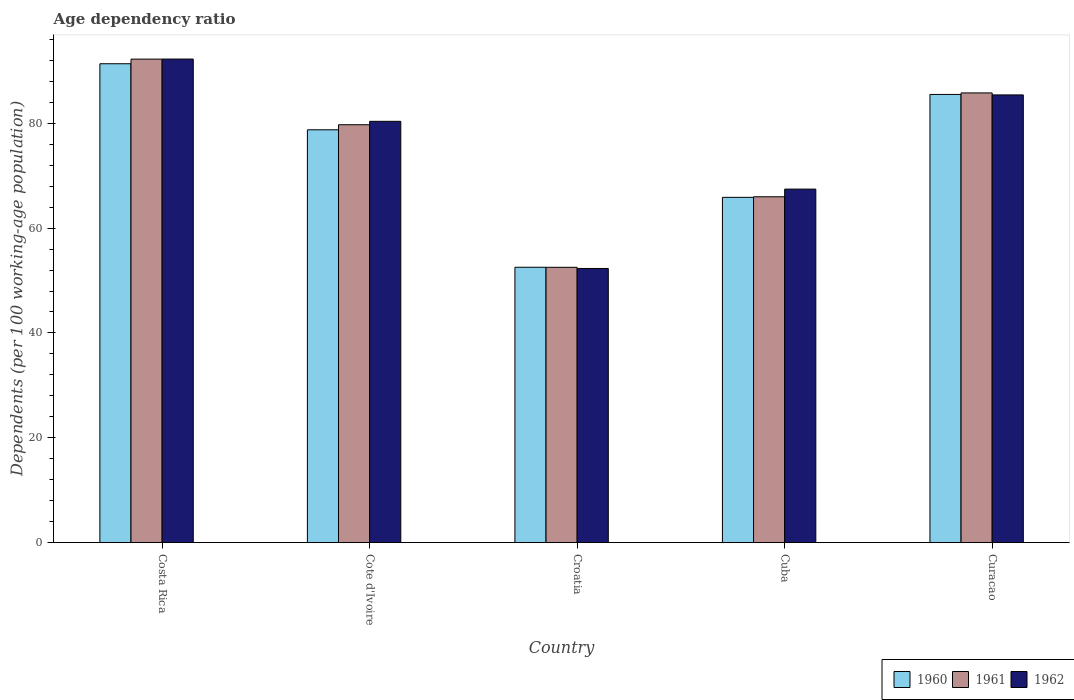How many different coloured bars are there?
Provide a succinct answer. 3. How many groups of bars are there?
Provide a short and direct response. 5. Are the number of bars per tick equal to the number of legend labels?
Your response must be concise. Yes. What is the label of the 3rd group of bars from the left?
Offer a terse response. Croatia. What is the age dependency ratio in in 1960 in Cuba?
Offer a terse response. 65.87. Across all countries, what is the maximum age dependency ratio in in 1962?
Provide a short and direct response. 92.26. Across all countries, what is the minimum age dependency ratio in in 1961?
Your response must be concise. 52.52. In which country was the age dependency ratio in in 1961 maximum?
Your response must be concise. Costa Rica. In which country was the age dependency ratio in in 1962 minimum?
Make the answer very short. Croatia. What is the total age dependency ratio in in 1962 in the graph?
Provide a succinct answer. 377.8. What is the difference between the age dependency ratio in in 1962 in Cote d'Ivoire and that in Curacao?
Provide a succinct answer. -5.04. What is the difference between the age dependency ratio in in 1960 in Curacao and the age dependency ratio in in 1961 in Croatia?
Provide a succinct answer. 32.98. What is the average age dependency ratio in in 1960 per country?
Your answer should be very brief. 74.81. What is the difference between the age dependency ratio in of/in 1960 and age dependency ratio in of/in 1961 in Cote d'Ivoire?
Offer a terse response. -0.97. What is the ratio of the age dependency ratio in in 1962 in Costa Rica to that in Curacao?
Ensure brevity in your answer.  1.08. Is the age dependency ratio in in 1961 in Croatia less than that in Curacao?
Keep it short and to the point. Yes. What is the difference between the highest and the second highest age dependency ratio in in 1961?
Keep it short and to the point. 6.45. What is the difference between the highest and the lowest age dependency ratio in in 1962?
Your response must be concise. 39.96. In how many countries, is the age dependency ratio in in 1962 greater than the average age dependency ratio in in 1962 taken over all countries?
Keep it short and to the point. 3. What does the 1st bar from the left in Costa Rica represents?
Your answer should be compact. 1960. What does the 1st bar from the right in Costa Rica represents?
Provide a short and direct response. 1962. Is it the case that in every country, the sum of the age dependency ratio in in 1960 and age dependency ratio in in 1962 is greater than the age dependency ratio in in 1961?
Provide a succinct answer. Yes. Are the values on the major ticks of Y-axis written in scientific E-notation?
Your answer should be compact. No. Does the graph contain grids?
Offer a very short reply. No. How many legend labels are there?
Your response must be concise. 3. What is the title of the graph?
Provide a short and direct response. Age dependency ratio. What is the label or title of the X-axis?
Give a very brief answer. Country. What is the label or title of the Y-axis?
Keep it short and to the point. Dependents (per 100 working-age population). What is the Dependents (per 100 working-age population) in 1960 in Costa Rica?
Your answer should be compact. 91.36. What is the Dependents (per 100 working-age population) of 1961 in Costa Rica?
Ensure brevity in your answer.  92.25. What is the Dependents (per 100 working-age population) in 1962 in Costa Rica?
Ensure brevity in your answer.  92.26. What is the Dependents (per 100 working-age population) of 1960 in Cote d'Ivoire?
Your response must be concise. 78.76. What is the Dependents (per 100 working-age population) in 1961 in Cote d'Ivoire?
Your answer should be compact. 79.73. What is the Dependents (per 100 working-age population) in 1962 in Cote d'Ivoire?
Provide a succinct answer. 80.38. What is the Dependents (per 100 working-age population) in 1960 in Croatia?
Keep it short and to the point. 52.53. What is the Dependents (per 100 working-age population) in 1961 in Croatia?
Your answer should be compact. 52.52. What is the Dependents (per 100 working-age population) of 1962 in Croatia?
Make the answer very short. 52.3. What is the Dependents (per 100 working-age population) in 1960 in Cuba?
Provide a succinct answer. 65.87. What is the Dependents (per 100 working-age population) in 1961 in Cuba?
Provide a succinct answer. 65.98. What is the Dependents (per 100 working-age population) of 1962 in Cuba?
Your response must be concise. 67.44. What is the Dependents (per 100 working-age population) of 1960 in Curacao?
Offer a very short reply. 85.5. What is the Dependents (per 100 working-age population) in 1961 in Curacao?
Your answer should be very brief. 85.8. What is the Dependents (per 100 working-age population) in 1962 in Curacao?
Offer a terse response. 85.42. Across all countries, what is the maximum Dependents (per 100 working-age population) in 1960?
Make the answer very short. 91.36. Across all countries, what is the maximum Dependents (per 100 working-age population) of 1961?
Give a very brief answer. 92.25. Across all countries, what is the maximum Dependents (per 100 working-age population) of 1962?
Your answer should be compact. 92.26. Across all countries, what is the minimum Dependents (per 100 working-age population) in 1960?
Provide a short and direct response. 52.53. Across all countries, what is the minimum Dependents (per 100 working-age population) of 1961?
Make the answer very short. 52.52. Across all countries, what is the minimum Dependents (per 100 working-age population) in 1962?
Provide a short and direct response. 52.3. What is the total Dependents (per 100 working-age population) of 1960 in the graph?
Offer a very short reply. 374.03. What is the total Dependents (per 100 working-age population) in 1961 in the graph?
Keep it short and to the point. 376.28. What is the total Dependents (per 100 working-age population) in 1962 in the graph?
Your response must be concise. 377.8. What is the difference between the Dependents (per 100 working-age population) of 1960 in Costa Rica and that in Cote d'Ivoire?
Your answer should be compact. 12.6. What is the difference between the Dependents (per 100 working-age population) of 1961 in Costa Rica and that in Cote d'Ivoire?
Offer a terse response. 12.52. What is the difference between the Dependents (per 100 working-age population) in 1962 in Costa Rica and that in Cote d'Ivoire?
Provide a short and direct response. 11.88. What is the difference between the Dependents (per 100 working-age population) in 1960 in Costa Rica and that in Croatia?
Keep it short and to the point. 38.83. What is the difference between the Dependents (per 100 working-age population) in 1961 in Costa Rica and that in Croatia?
Provide a succinct answer. 39.72. What is the difference between the Dependents (per 100 working-age population) of 1962 in Costa Rica and that in Croatia?
Provide a short and direct response. 39.96. What is the difference between the Dependents (per 100 working-age population) in 1960 in Costa Rica and that in Cuba?
Provide a short and direct response. 25.49. What is the difference between the Dependents (per 100 working-age population) in 1961 in Costa Rica and that in Cuba?
Your answer should be very brief. 26.27. What is the difference between the Dependents (per 100 working-age population) in 1962 in Costa Rica and that in Cuba?
Offer a terse response. 24.81. What is the difference between the Dependents (per 100 working-age population) in 1960 in Costa Rica and that in Curacao?
Your answer should be very brief. 5.86. What is the difference between the Dependents (per 100 working-age population) of 1961 in Costa Rica and that in Curacao?
Give a very brief answer. 6.45. What is the difference between the Dependents (per 100 working-age population) of 1962 in Costa Rica and that in Curacao?
Offer a terse response. 6.84. What is the difference between the Dependents (per 100 working-age population) of 1960 in Cote d'Ivoire and that in Croatia?
Offer a terse response. 26.23. What is the difference between the Dependents (per 100 working-age population) in 1961 in Cote d'Ivoire and that in Croatia?
Provide a short and direct response. 27.2. What is the difference between the Dependents (per 100 working-age population) in 1962 in Cote d'Ivoire and that in Croatia?
Ensure brevity in your answer.  28.08. What is the difference between the Dependents (per 100 working-age population) of 1960 in Cote d'Ivoire and that in Cuba?
Offer a terse response. 12.89. What is the difference between the Dependents (per 100 working-age population) of 1961 in Cote d'Ivoire and that in Cuba?
Your response must be concise. 13.75. What is the difference between the Dependents (per 100 working-age population) of 1962 in Cote d'Ivoire and that in Cuba?
Ensure brevity in your answer.  12.93. What is the difference between the Dependents (per 100 working-age population) in 1960 in Cote d'Ivoire and that in Curacao?
Offer a very short reply. -6.75. What is the difference between the Dependents (per 100 working-age population) in 1961 in Cote d'Ivoire and that in Curacao?
Your response must be concise. -6.07. What is the difference between the Dependents (per 100 working-age population) of 1962 in Cote d'Ivoire and that in Curacao?
Provide a succinct answer. -5.04. What is the difference between the Dependents (per 100 working-age population) of 1960 in Croatia and that in Cuba?
Your response must be concise. -13.34. What is the difference between the Dependents (per 100 working-age population) of 1961 in Croatia and that in Cuba?
Offer a very short reply. -13.46. What is the difference between the Dependents (per 100 working-age population) of 1962 in Croatia and that in Cuba?
Offer a very short reply. -15.14. What is the difference between the Dependents (per 100 working-age population) in 1960 in Croatia and that in Curacao?
Keep it short and to the point. -32.97. What is the difference between the Dependents (per 100 working-age population) in 1961 in Croatia and that in Curacao?
Provide a short and direct response. -33.27. What is the difference between the Dependents (per 100 working-age population) in 1962 in Croatia and that in Curacao?
Your answer should be compact. -33.12. What is the difference between the Dependents (per 100 working-age population) of 1960 in Cuba and that in Curacao?
Offer a very short reply. -19.63. What is the difference between the Dependents (per 100 working-age population) of 1961 in Cuba and that in Curacao?
Your answer should be very brief. -19.82. What is the difference between the Dependents (per 100 working-age population) in 1962 in Cuba and that in Curacao?
Give a very brief answer. -17.97. What is the difference between the Dependents (per 100 working-age population) of 1960 in Costa Rica and the Dependents (per 100 working-age population) of 1961 in Cote d'Ivoire?
Offer a very short reply. 11.63. What is the difference between the Dependents (per 100 working-age population) in 1960 in Costa Rica and the Dependents (per 100 working-age population) in 1962 in Cote d'Ivoire?
Offer a terse response. 10.98. What is the difference between the Dependents (per 100 working-age population) of 1961 in Costa Rica and the Dependents (per 100 working-age population) of 1962 in Cote d'Ivoire?
Ensure brevity in your answer.  11.87. What is the difference between the Dependents (per 100 working-age population) of 1960 in Costa Rica and the Dependents (per 100 working-age population) of 1961 in Croatia?
Give a very brief answer. 38.84. What is the difference between the Dependents (per 100 working-age population) in 1960 in Costa Rica and the Dependents (per 100 working-age population) in 1962 in Croatia?
Offer a very short reply. 39.06. What is the difference between the Dependents (per 100 working-age population) in 1961 in Costa Rica and the Dependents (per 100 working-age population) in 1962 in Croatia?
Make the answer very short. 39.95. What is the difference between the Dependents (per 100 working-age population) of 1960 in Costa Rica and the Dependents (per 100 working-age population) of 1961 in Cuba?
Give a very brief answer. 25.38. What is the difference between the Dependents (per 100 working-age population) of 1960 in Costa Rica and the Dependents (per 100 working-age population) of 1962 in Cuba?
Your answer should be compact. 23.92. What is the difference between the Dependents (per 100 working-age population) in 1961 in Costa Rica and the Dependents (per 100 working-age population) in 1962 in Cuba?
Ensure brevity in your answer.  24.8. What is the difference between the Dependents (per 100 working-age population) of 1960 in Costa Rica and the Dependents (per 100 working-age population) of 1961 in Curacao?
Your answer should be compact. 5.57. What is the difference between the Dependents (per 100 working-age population) of 1960 in Costa Rica and the Dependents (per 100 working-age population) of 1962 in Curacao?
Provide a short and direct response. 5.95. What is the difference between the Dependents (per 100 working-age population) in 1961 in Costa Rica and the Dependents (per 100 working-age population) in 1962 in Curacao?
Ensure brevity in your answer.  6.83. What is the difference between the Dependents (per 100 working-age population) of 1960 in Cote d'Ivoire and the Dependents (per 100 working-age population) of 1961 in Croatia?
Ensure brevity in your answer.  26.23. What is the difference between the Dependents (per 100 working-age population) in 1960 in Cote d'Ivoire and the Dependents (per 100 working-age population) in 1962 in Croatia?
Offer a very short reply. 26.46. What is the difference between the Dependents (per 100 working-age population) in 1961 in Cote d'Ivoire and the Dependents (per 100 working-age population) in 1962 in Croatia?
Your answer should be very brief. 27.43. What is the difference between the Dependents (per 100 working-age population) in 1960 in Cote d'Ivoire and the Dependents (per 100 working-age population) in 1961 in Cuba?
Provide a succinct answer. 12.78. What is the difference between the Dependents (per 100 working-age population) in 1960 in Cote d'Ivoire and the Dependents (per 100 working-age population) in 1962 in Cuba?
Keep it short and to the point. 11.31. What is the difference between the Dependents (per 100 working-age population) of 1961 in Cote d'Ivoire and the Dependents (per 100 working-age population) of 1962 in Cuba?
Offer a terse response. 12.28. What is the difference between the Dependents (per 100 working-age population) of 1960 in Cote d'Ivoire and the Dependents (per 100 working-age population) of 1961 in Curacao?
Make the answer very short. -7.04. What is the difference between the Dependents (per 100 working-age population) of 1960 in Cote d'Ivoire and the Dependents (per 100 working-age population) of 1962 in Curacao?
Your answer should be very brief. -6.66. What is the difference between the Dependents (per 100 working-age population) of 1961 in Cote d'Ivoire and the Dependents (per 100 working-age population) of 1962 in Curacao?
Your answer should be very brief. -5.69. What is the difference between the Dependents (per 100 working-age population) in 1960 in Croatia and the Dependents (per 100 working-age population) in 1961 in Cuba?
Your response must be concise. -13.45. What is the difference between the Dependents (per 100 working-age population) of 1960 in Croatia and the Dependents (per 100 working-age population) of 1962 in Cuba?
Your answer should be compact. -14.91. What is the difference between the Dependents (per 100 working-age population) of 1961 in Croatia and the Dependents (per 100 working-age population) of 1962 in Cuba?
Give a very brief answer. -14.92. What is the difference between the Dependents (per 100 working-age population) of 1960 in Croatia and the Dependents (per 100 working-age population) of 1961 in Curacao?
Provide a succinct answer. -33.26. What is the difference between the Dependents (per 100 working-age population) in 1960 in Croatia and the Dependents (per 100 working-age population) in 1962 in Curacao?
Provide a succinct answer. -32.88. What is the difference between the Dependents (per 100 working-age population) in 1961 in Croatia and the Dependents (per 100 working-age population) in 1962 in Curacao?
Your response must be concise. -32.89. What is the difference between the Dependents (per 100 working-age population) of 1960 in Cuba and the Dependents (per 100 working-age population) of 1961 in Curacao?
Make the answer very short. -19.93. What is the difference between the Dependents (per 100 working-age population) of 1960 in Cuba and the Dependents (per 100 working-age population) of 1962 in Curacao?
Give a very brief answer. -19.55. What is the difference between the Dependents (per 100 working-age population) of 1961 in Cuba and the Dependents (per 100 working-age population) of 1962 in Curacao?
Your answer should be compact. -19.44. What is the average Dependents (per 100 working-age population) of 1960 per country?
Give a very brief answer. 74.81. What is the average Dependents (per 100 working-age population) of 1961 per country?
Keep it short and to the point. 75.26. What is the average Dependents (per 100 working-age population) in 1962 per country?
Your response must be concise. 75.56. What is the difference between the Dependents (per 100 working-age population) of 1960 and Dependents (per 100 working-age population) of 1961 in Costa Rica?
Make the answer very short. -0.88. What is the difference between the Dependents (per 100 working-age population) of 1960 and Dependents (per 100 working-age population) of 1962 in Costa Rica?
Provide a succinct answer. -0.9. What is the difference between the Dependents (per 100 working-age population) in 1961 and Dependents (per 100 working-age population) in 1962 in Costa Rica?
Keep it short and to the point. -0.01. What is the difference between the Dependents (per 100 working-age population) in 1960 and Dependents (per 100 working-age population) in 1961 in Cote d'Ivoire?
Offer a very short reply. -0.97. What is the difference between the Dependents (per 100 working-age population) of 1960 and Dependents (per 100 working-age population) of 1962 in Cote d'Ivoire?
Offer a terse response. -1.62. What is the difference between the Dependents (per 100 working-age population) in 1961 and Dependents (per 100 working-age population) in 1962 in Cote d'Ivoire?
Offer a terse response. -0.65. What is the difference between the Dependents (per 100 working-age population) in 1960 and Dependents (per 100 working-age population) in 1961 in Croatia?
Ensure brevity in your answer.  0.01. What is the difference between the Dependents (per 100 working-age population) in 1960 and Dependents (per 100 working-age population) in 1962 in Croatia?
Give a very brief answer. 0.23. What is the difference between the Dependents (per 100 working-age population) of 1961 and Dependents (per 100 working-age population) of 1962 in Croatia?
Provide a short and direct response. 0.23. What is the difference between the Dependents (per 100 working-age population) in 1960 and Dependents (per 100 working-age population) in 1961 in Cuba?
Your response must be concise. -0.11. What is the difference between the Dependents (per 100 working-age population) of 1960 and Dependents (per 100 working-age population) of 1962 in Cuba?
Make the answer very short. -1.57. What is the difference between the Dependents (per 100 working-age population) of 1961 and Dependents (per 100 working-age population) of 1962 in Cuba?
Your answer should be very brief. -1.46. What is the difference between the Dependents (per 100 working-age population) in 1960 and Dependents (per 100 working-age population) in 1961 in Curacao?
Ensure brevity in your answer.  -0.29. What is the difference between the Dependents (per 100 working-age population) of 1960 and Dependents (per 100 working-age population) of 1962 in Curacao?
Provide a short and direct response. 0.09. What is the difference between the Dependents (per 100 working-age population) of 1961 and Dependents (per 100 working-age population) of 1962 in Curacao?
Offer a very short reply. 0.38. What is the ratio of the Dependents (per 100 working-age population) of 1960 in Costa Rica to that in Cote d'Ivoire?
Provide a short and direct response. 1.16. What is the ratio of the Dependents (per 100 working-age population) of 1961 in Costa Rica to that in Cote d'Ivoire?
Your answer should be compact. 1.16. What is the ratio of the Dependents (per 100 working-age population) of 1962 in Costa Rica to that in Cote d'Ivoire?
Your answer should be compact. 1.15. What is the ratio of the Dependents (per 100 working-age population) of 1960 in Costa Rica to that in Croatia?
Your answer should be very brief. 1.74. What is the ratio of the Dependents (per 100 working-age population) in 1961 in Costa Rica to that in Croatia?
Provide a succinct answer. 1.76. What is the ratio of the Dependents (per 100 working-age population) of 1962 in Costa Rica to that in Croatia?
Offer a very short reply. 1.76. What is the ratio of the Dependents (per 100 working-age population) in 1960 in Costa Rica to that in Cuba?
Offer a very short reply. 1.39. What is the ratio of the Dependents (per 100 working-age population) of 1961 in Costa Rica to that in Cuba?
Your response must be concise. 1.4. What is the ratio of the Dependents (per 100 working-age population) in 1962 in Costa Rica to that in Cuba?
Your answer should be compact. 1.37. What is the ratio of the Dependents (per 100 working-age population) in 1960 in Costa Rica to that in Curacao?
Keep it short and to the point. 1.07. What is the ratio of the Dependents (per 100 working-age population) in 1961 in Costa Rica to that in Curacao?
Ensure brevity in your answer.  1.08. What is the ratio of the Dependents (per 100 working-age population) in 1962 in Costa Rica to that in Curacao?
Provide a short and direct response. 1.08. What is the ratio of the Dependents (per 100 working-age population) of 1960 in Cote d'Ivoire to that in Croatia?
Your response must be concise. 1.5. What is the ratio of the Dependents (per 100 working-age population) of 1961 in Cote d'Ivoire to that in Croatia?
Your answer should be very brief. 1.52. What is the ratio of the Dependents (per 100 working-age population) in 1962 in Cote d'Ivoire to that in Croatia?
Make the answer very short. 1.54. What is the ratio of the Dependents (per 100 working-age population) in 1960 in Cote d'Ivoire to that in Cuba?
Make the answer very short. 1.2. What is the ratio of the Dependents (per 100 working-age population) in 1961 in Cote d'Ivoire to that in Cuba?
Keep it short and to the point. 1.21. What is the ratio of the Dependents (per 100 working-age population) of 1962 in Cote d'Ivoire to that in Cuba?
Offer a very short reply. 1.19. What is the ratio of the Dependents (per 100 working-age population) of 1960 in Cote d'Ivoire to that in Curacao?
Provide a short and direct response. 0.92. What is the ratio of the Dependents (per 100 working-age population) of 1961 in Cote d'Ivoire to that in Curacao?
Make the answer very short. 0.93. What is the ratio of the Dependents (per 100 working-age population) of 1962 in Cote d'Ivoire to that in Curacao?
Your response must be concise. 0.94. What is the ratio of the Dependents (per 100 working-age population) of 1960 in Croatia to that in Cuba?
Give a very brief answer. 0.8. What is the ratio of the Dependents (per 100 working-age population) of 1961 in Croatia to that in Cuba?
Keep it short and to the point. 0.8. What is the ratio of the Dependents (per 100 working-age population) of 1962 in Croatia to that in Cuba?
Your answer should be very brief. 0.78. What is the ratio of the Dependents (per 100 working-age population) in 1960 in Croatia to that in Curacao?
Your response must be concise. 0.61. What is the ratio of the Dependents (per 100 working-age population) in 1961 in Croatia to that in Curacao?
Make the answer very short. 0.61. What is the ratio of the Dependents (per 100 working-age population) in 1962 in Croatia to that in Curacao?
Ensure brevity in your answer.  0.61. What is the ratio of the Dependents (per 100 working-age population) in 1960 in Cuba to that in Curacao?
Ensure brevity in your answer.  0.77. What is the ratio of the Dependents (per 100 working-age population) of 1961 in Cuba to that in Curacao?
Keep it short and to the point. 0.77. What is the ratio of the Dependents (per 100 working-age population) in 1962 in Cuba to that in Curacao?
Provide a succinct answer. 0.79. What is the difference between the highest and the second highest Dependents (per 100 working-age population) of 1960?
Your answer should be very brief. 5.86. What is the difference between the highest and the second highest Dependents (per 100 working-age population) of 1961?
Keep it short and to the point. 6.45. What is the difference between the highest and the second highest Dependents (per 100 working-age population) in 1962?
Ensure brevity in your answer.  6.84. What is the difference between the highest and the lowest Dependents (per 100 working-age population) of 1960?
Provide a succinct answer. 38.83. What is the difference between the highest and the lowest Dependents (per 100 working-age population) in 1961?
Provide a short and direct response. 39.72. What is the difference between the highest and the lowest Dependents (per 100 working-age population) of 1962?
Your answer should be compact. 39.96. 